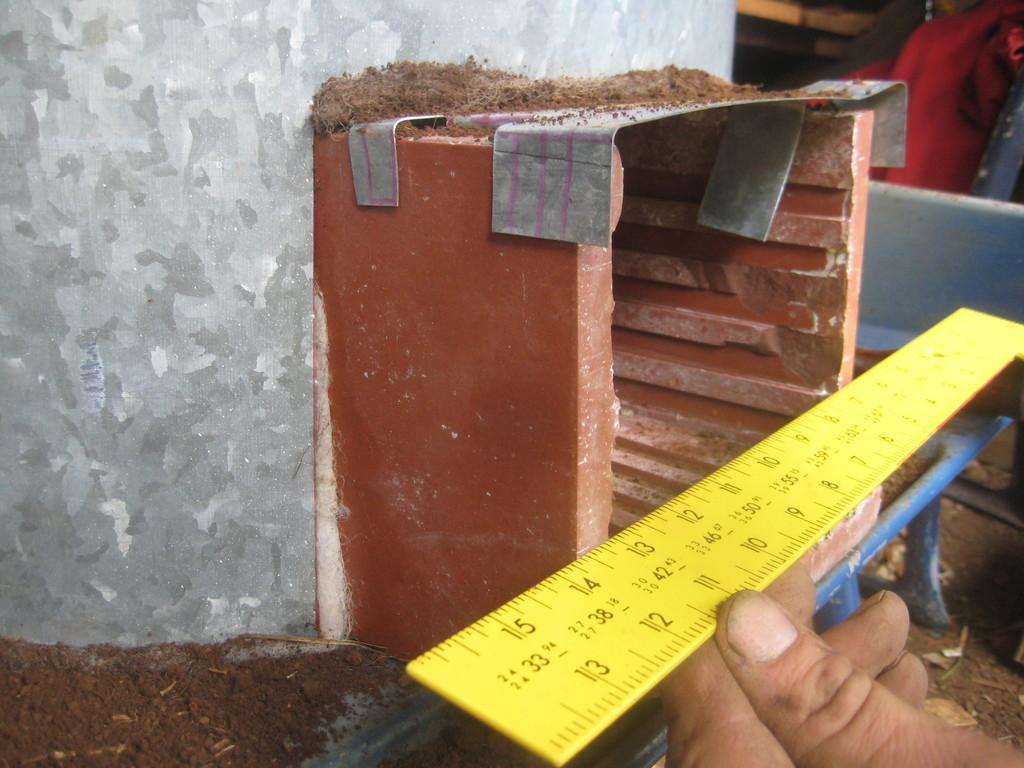<image>
Provide a brief description of the given image. A yellow ruler has 15 and 13 on the left side. 